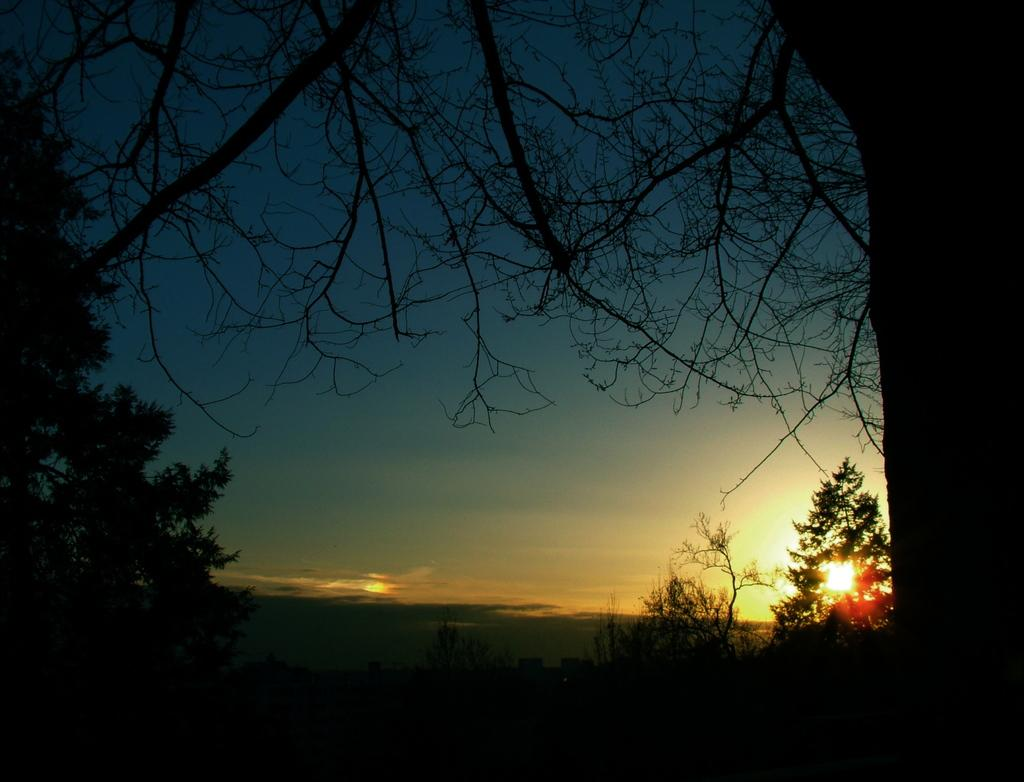What can be seen in the sky in the image? The sky is visible in the image. What type of vegetation is present in the image? There are trees in the image. What type of structures can be seen in the image? There are buildings in the image. What celestial body is visible in the image? The sun is observable in the image. Can you tell me how many snails are crawling on the buildings in the image? There are no snails present in the image; it only features the sky, trees, buildings, and the sun. 